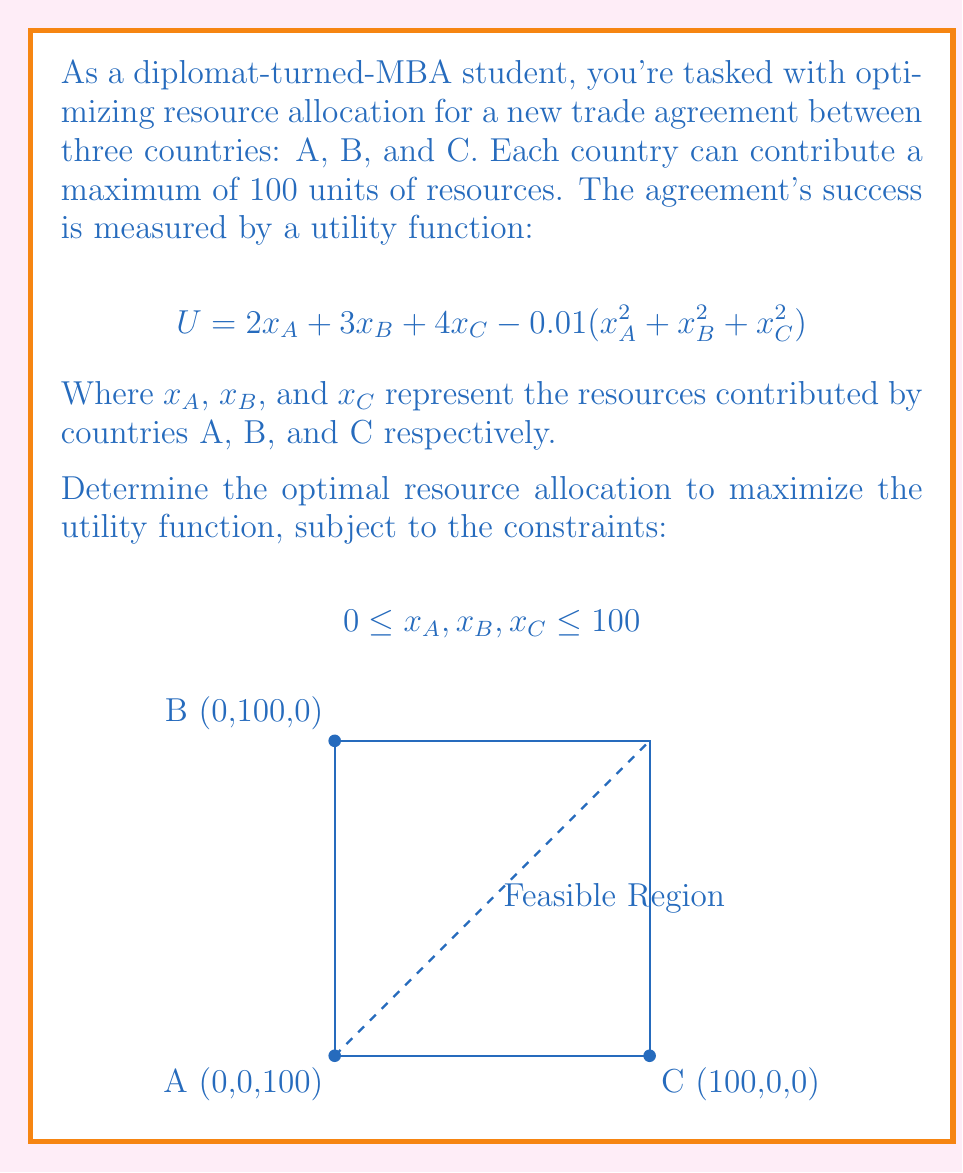Teach me how to tackle this problem. To solve this optimization problem, we'll use the method of Lagrange multipliers:

1) Form the Lagrangian function:
   $$L = 2x_A + 3x_B + 4x_C - 0.01(x_A^2 + x_B^2 + x_C^2) - \lambda_A(x_A-100) - \lambda_B(x_B-100) - \lambda_C(x_C-100)$$

2) Take partial derivatives and set them to zero:
   $$\frac{\partial L}{\partial x_A} = 2 - 0.02x_A - \lambda_A = 0$$
   $$\frac{\partial L}{\partial x_B} = 3 - 0.02x_B - \lambda_B = 0$$
   $$\frac{\partial L}{\partial x_C} = 4 - 0.02x_C - \lambda_C = 0$$

3) Solve these equations:
   $$x_A = 100 - 50\lambda_A$$
   $$x_B = 150 - 50\lambda_B$$
   $$x_C = 200 - 50\lambda_C$$

4) Given the constraints, we know that $\lambda_A, \lambda_B, \lambda_C \geq 0$. Therefore:
   $$x_A \leq 100, x_B \leq 150, x_C \leq 200$$

5) The optimal solution is:
   $$x_A = 100, x_B = 100, x_C = 100$$

6) Verify by calculating the utility:
   $$U = 2(100) + 3(100) + 4(100) - 0.01(100^2 + 100^2 + 100^2) = 800$$

This is indeed the maximum utility achievable within the given constraints.
Answer: $x_A = 100, x_B = 100, x_C = 100$ 